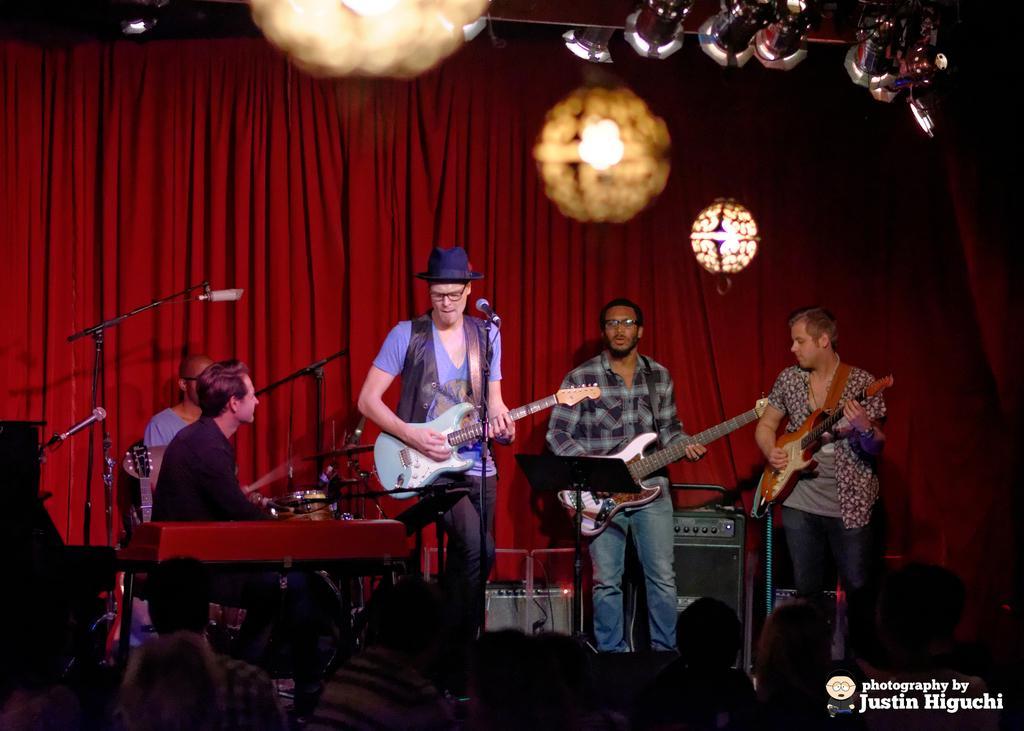Can you describe this image briefly? In the left bottom, there are two people sitting on the chair and playing musical instruments. In the right middle, there are three person standing in front of the mike and playing guitar. On the top there are lights hanged. In the background there are curtains red in color. At the bottom there are group of people sitting. At the bottom right text is there. This image is taken inside a stage during night time. 